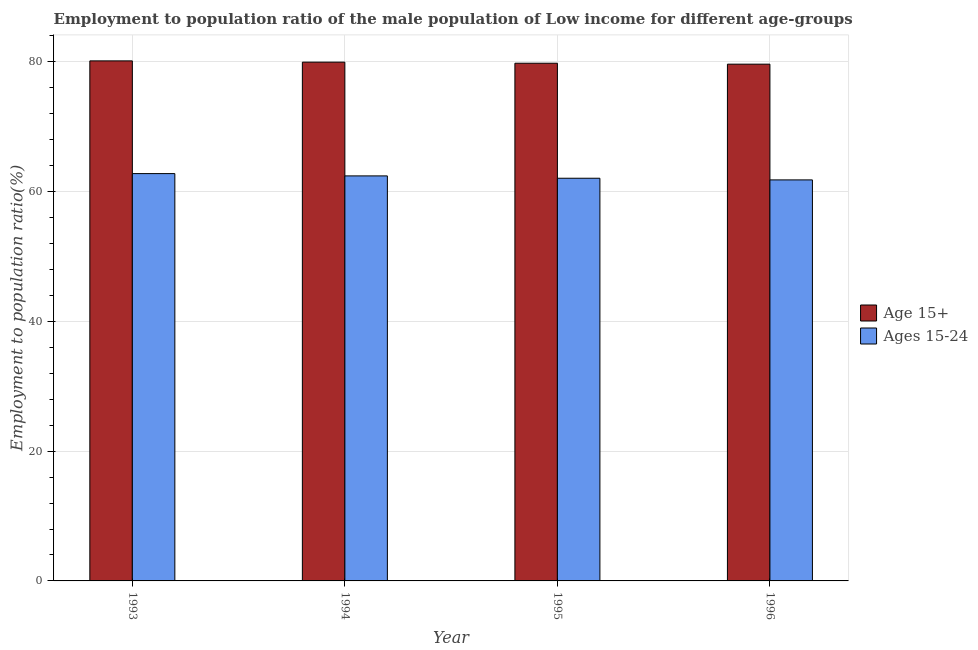Are the number of bars per tick equal to the number of legend labels?
Your answer should be very brief. Yes. How many bars are there on the 2nd tick from the left?
Your answer should be compact. 2. How many bars are there on the 2nd tick from the right?
Keep it short and to the point. 2. What is the employment to population ratio(age 15+) in 1993?
Your answer should be compact. 80.14. Across all years, what is the maximum employment to population ratio(age 15+)?
Your answer should be compact. 80.14. Across all years, what is the minimum employment to population ratio(age 15+)?
Give a very brief answer. 79.63. In which year was the employment to population ratio(age 15+) minimum?
Ensure brevity in your answer.  1996. What is the total employment to population ratio(age 15+) in the graph?
Your answer should be compact. 319.48. What is the difference between the employment to population ratio(age 15+) in 1995 and that in 1996?
Make the answer very short. 0.14. What is the difference between the employment to population ratio(age 15-24) in 1995 and the employment to population ratio(age 15+) in 1996?
Make the answer very short. 0.25. What is the average employment to population ratio(age 15-24) per year?
Your response must be concise. 62.26. What is the ratio of the employment to population ratio(age 15-24) in 1994 to that in 1996?
Provide a short and direct response. 1.01. Is the employment to population ratio(age 15+) in 1995 less than that in 1996?
Provide a short and direct response. No. Is the difference between the employment to population ratio(age 15+) in 1994 and 1996 greater than the difference between the employment to population ratio(age 15-24) in 1994 and 1996?
Your answer should be compact. No. What is the difference between the highest and the second highest employment to population ratio(age 15-24)?
Provide a short and direct response. 0.35. What is the difference between the highest and the lowest employment to population ratio(age 15+)?
Keep it short and to the point. 0.51. In how many years, is the employment to population ratio(age 15+) greater than the average employment to population ratio(age 15+) taken over all years?
Keep it short and to the point. 2. What does the 2nd bar from the left in 1995 represents?
Make the answer very short. Ages 15-24. What does the 1st bar from the right in 1995 represents?
Your response must be concise. Ages 15-24. How many bars are there?
Give a very brief answer. 8. How many years are there in the graph?
Offer a terse response. 4. Are the values on the major ticks of Y-axis written in scientific E-notation?
Your response must be concise. No. Does the graph contain any zero values?
Offer a terse response. No. Does the graph contain grids?
Offer a terse response. Yes. What is the title of the graph?
Your answer should be very brief. Employment to population ratio of the male population of Low income for different age-groups. Does "Mineral" appear as one of the legend labels in the graph?
Keep it short and to the point. No. What is the label or title of the X-axis?
Your answer should be very brief. Year. What is the label or title of the Y-axis?
Keep it short and to the point. Employment to population ratio(%). What is the Employment to population ratio(%) of Age 15+ in 1993?
Your answer should be very brief. 80.14. What is the Employment to population ratio(%) of Ages 15-24 in 1993?
Provide a short and direct response. 62.77. What is the Employment to population ratio(%) in Age 15+ in 1994?
Provide a succinct answer. 79.94. What is the Employment to population ratio(%) of Ages 15-24 in 1994?
Keep it short and to the point. 62.41. What is the Employment to population ratio(%) in Age 15+ in 1995?
Your answer should be compact. 79.77. What is the Employment to population ratio(%) of Ages 15-24 in 1995?
Provide a succinct answer. 62.05. What is the Employment to population ratio(%) of Age 15+ in 1996?
Your answer should be very brief. 79.63. What is the Employment to population ratio(%) of Ages 15-24 in 1996?
Keep it short and to the point. 61.8. Across all years, what is the maximum Employment to population ratio(%) of Age 15+?
Provide a short and direct response. 80.14. Across all years, what is the maximum Employment to population ratio(%) in Ages 15-24?
Your answer should be compact. 62.77. Across all years, what is the minimum Employment to population ratio(%) in Age 15+?
Provide a short and direct response. 79.63. Across all years, what is the minimum Employment to population ratio(%) in Ages 15-24?
Offer a terse response. 61.8. What is the total Employment to population ratio(%) in Age 15+ in the graph?
Your answer should be very brief. 319.48. What is the total Employment to population ratio(%) of Ages 15-24 in the graph?
Your answer should be very brief. 249.02. What is the difference between the Employment to population ratio(%) in Age 15+ in 1993 and that in 1994?
Offer a terse response. 0.19. What is the difference between the Employment to population ratio(%) in Ages 15-24 in 1993 and that in 1994?
Provide a short and direct response. 0.35. What is the difference between the Employment to population ratio(%) in Age 15+ in 1993 and that in 1995?
Make the answer very short. 0.36. What is the difference between the Employment to population ratio(%) of Ages 15-24 in 1993 and that in 1995?
Provide a succinct answer. 0.72. What is the difference between the Employment to population ratio(%) of Age 15+ in 1993 and that in 1996?
Offer a terse response. 0.51. What is the difference between the Employment to population ratio(%) of Ages 15-24 in 1993 and that in 1996?
Offer a very short reply. 0.97. What is the difference between the Employment to population ratio(%) of Age 15+ in 1994 and that in 1995?
Your answer should be compact. 0.17. What is the difference between the Employment to population ratio(%) of Ages 15-24 in 1994 and that in 1995?
Your answer should be very brief. 0.36. What is the difference between the Employment to population ratio(%) of Age 15+ in 1994 and that in 1996?
Your answer should be compact. 0.31. What is the difference between the Employment to population ratio(%) in Ages 15-24 in 1994 and that in 1996?
Give a very brief answer. 0.61. What is the difference between the Employment to population ratio(%) in Age 15+ in 1995 and that in 1996?
Offer a terse response. 0.14. What is the difference between the Employment to population ratio(%) of Ages 15-24 in 1995 and that in 1996?
Provide a short and direct response. 0.25. What is the difference between the Employment to population ratio(%) of Age 15+ in 1993 and the Employment to population ratio(%) of Ages 15-24 in 1994?
Your answer should be very brief. 17.72. What is the difference between the Employment to population ratio(%) in Age 15+ in 1993 and the Employment to population ratio(%) in Ages 15-24 in 1995?
Offer a terse response. 18.09. What is the difference between the Employment to population ratio(%) in Age 15+ in 1993 and the Employment to population ratio(%) in Ages 15-24 in 1996?
Make the answer very short. 18.34. What is the difference between the Employment to population ratio(%) in Age 15+ in 1994 and the Employment to population ratio(%) in Ages 15-24 in 1995?
Provide a short and direct response. 17.89. What is the difference between the Employment to population ratio(%) in Age 15+ in 1994 and the Employment to population ratio(%) in Ages 15-24 in 1996?
Offer a terse response. 18.14. What is the difference between the Employment to population ratio(%) of Age 15+ in 1995 and the Employment to population ratio(%) of Ages 15-24 in 1996?
Provide a succinct answer. 17.98. What is the average Employment to population ratio(%) in Age 15+ per year?
Give a very brief answer. 79.87. What is the average Employment to population ratio(%) in Ages 15-24 per year?
Keep it short and to the point. 62.26. In the year 1993, what is the difference between the Employment to population ratio(%) of Age 15+ and Employment to population ratio(%) of Ages 15-24?
Offer a very short reply. 17.37. In the year 1994, what is the difference between the Employment to population ratio(%) of Age 15+ and Employment to population ratio(%) of Ages 15-24?
Keep it short and to the point. 17.53. In the year 1995, what is the difference between the Employment to population ratio(%) of Age 15+ and Employment to population ratio(%) of Ages 15-24?
Make the answer very short. 17.72. In the year 1996, what is the difference between the Employment to population ratio(%) in Age 15+ and Employment to population ratio(%) in Ages 15-24?
Offer a terse response. 17.83. What is the ratio of the Employment to population ratio(%) of Age 15+ in 1993 to that in 1994?
Your answer should be very brief. 1. What is the ratio of the Employment to population ratio(%) of Ages 15-24 in 1993 to that in 1994?
Ensure brevity in your answer.  1.01. What is the ratio of the Employment to population ratio(%) of Ages 15-24 in 1993 to that in 1995?
Offer a terse response. 1.01. What is the ratio of the Employment to population ratio(%) in Age 15+ in 1993 to that in 1996?
Your answer should be compact. 1.01. What is the ratio of the Employment to population ratio(%) of Ages 15-24 in 1993 to that in 1996?
Your answer should be very brief. 1.02. What is the ratio of the Employment to population ratio(%) in Age 15+ in 1994 to that in 1995?
Your response must be concise. 1. What is the ratio of the Employment to population ratio(%) of Ages 15-24 in 1994 to that in 1995?
Your answer should be very brief. 1.01. What is the ratio of the Employment to population ratio(%) in Ages 15-24 in 1995 to that in 1996?
Offer a terse response. 1. What is the difference between the highest and the second highest Employment to population ratio(%) of Age 15+?
Keep it short and to the point. 0.19. What is the difference between the highest and the second highest Employment to population ratio(%) in Ages 15-24?
Make the answer very short. 0.35. What is the difference between the highest and the lowest Employment to population ratio(%) of Age 15+?
Ensure brevity in your answer.  0.51. What is the difference between the highest and the lowest Employment to population ratio(%) of Ages 15-24?
Offer a terse response. 0.97. 